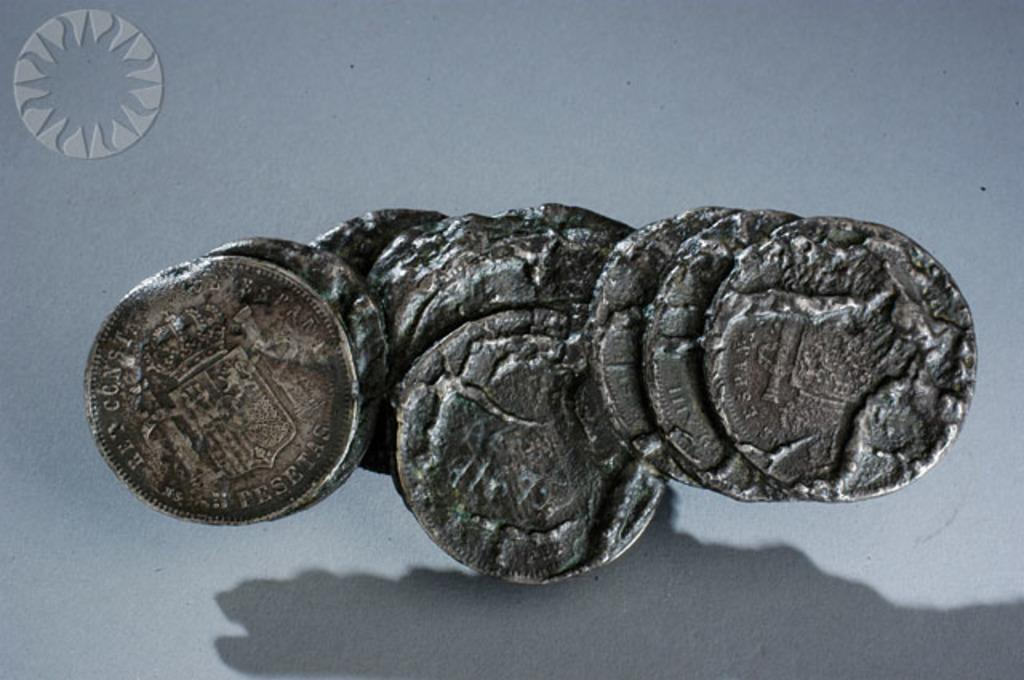What type of objects are present in the image? There are currency coins in the image. How are the coins arranged or positioned? The coins are stuck to each other. What colors can be seen on the coins? The coins are brown and black in color. What is the color of the background in the image? The background of the image is white. What type of milk is being poured from the clocks in the image? There are no clocks or milk present in the image; it only features currency coins. 